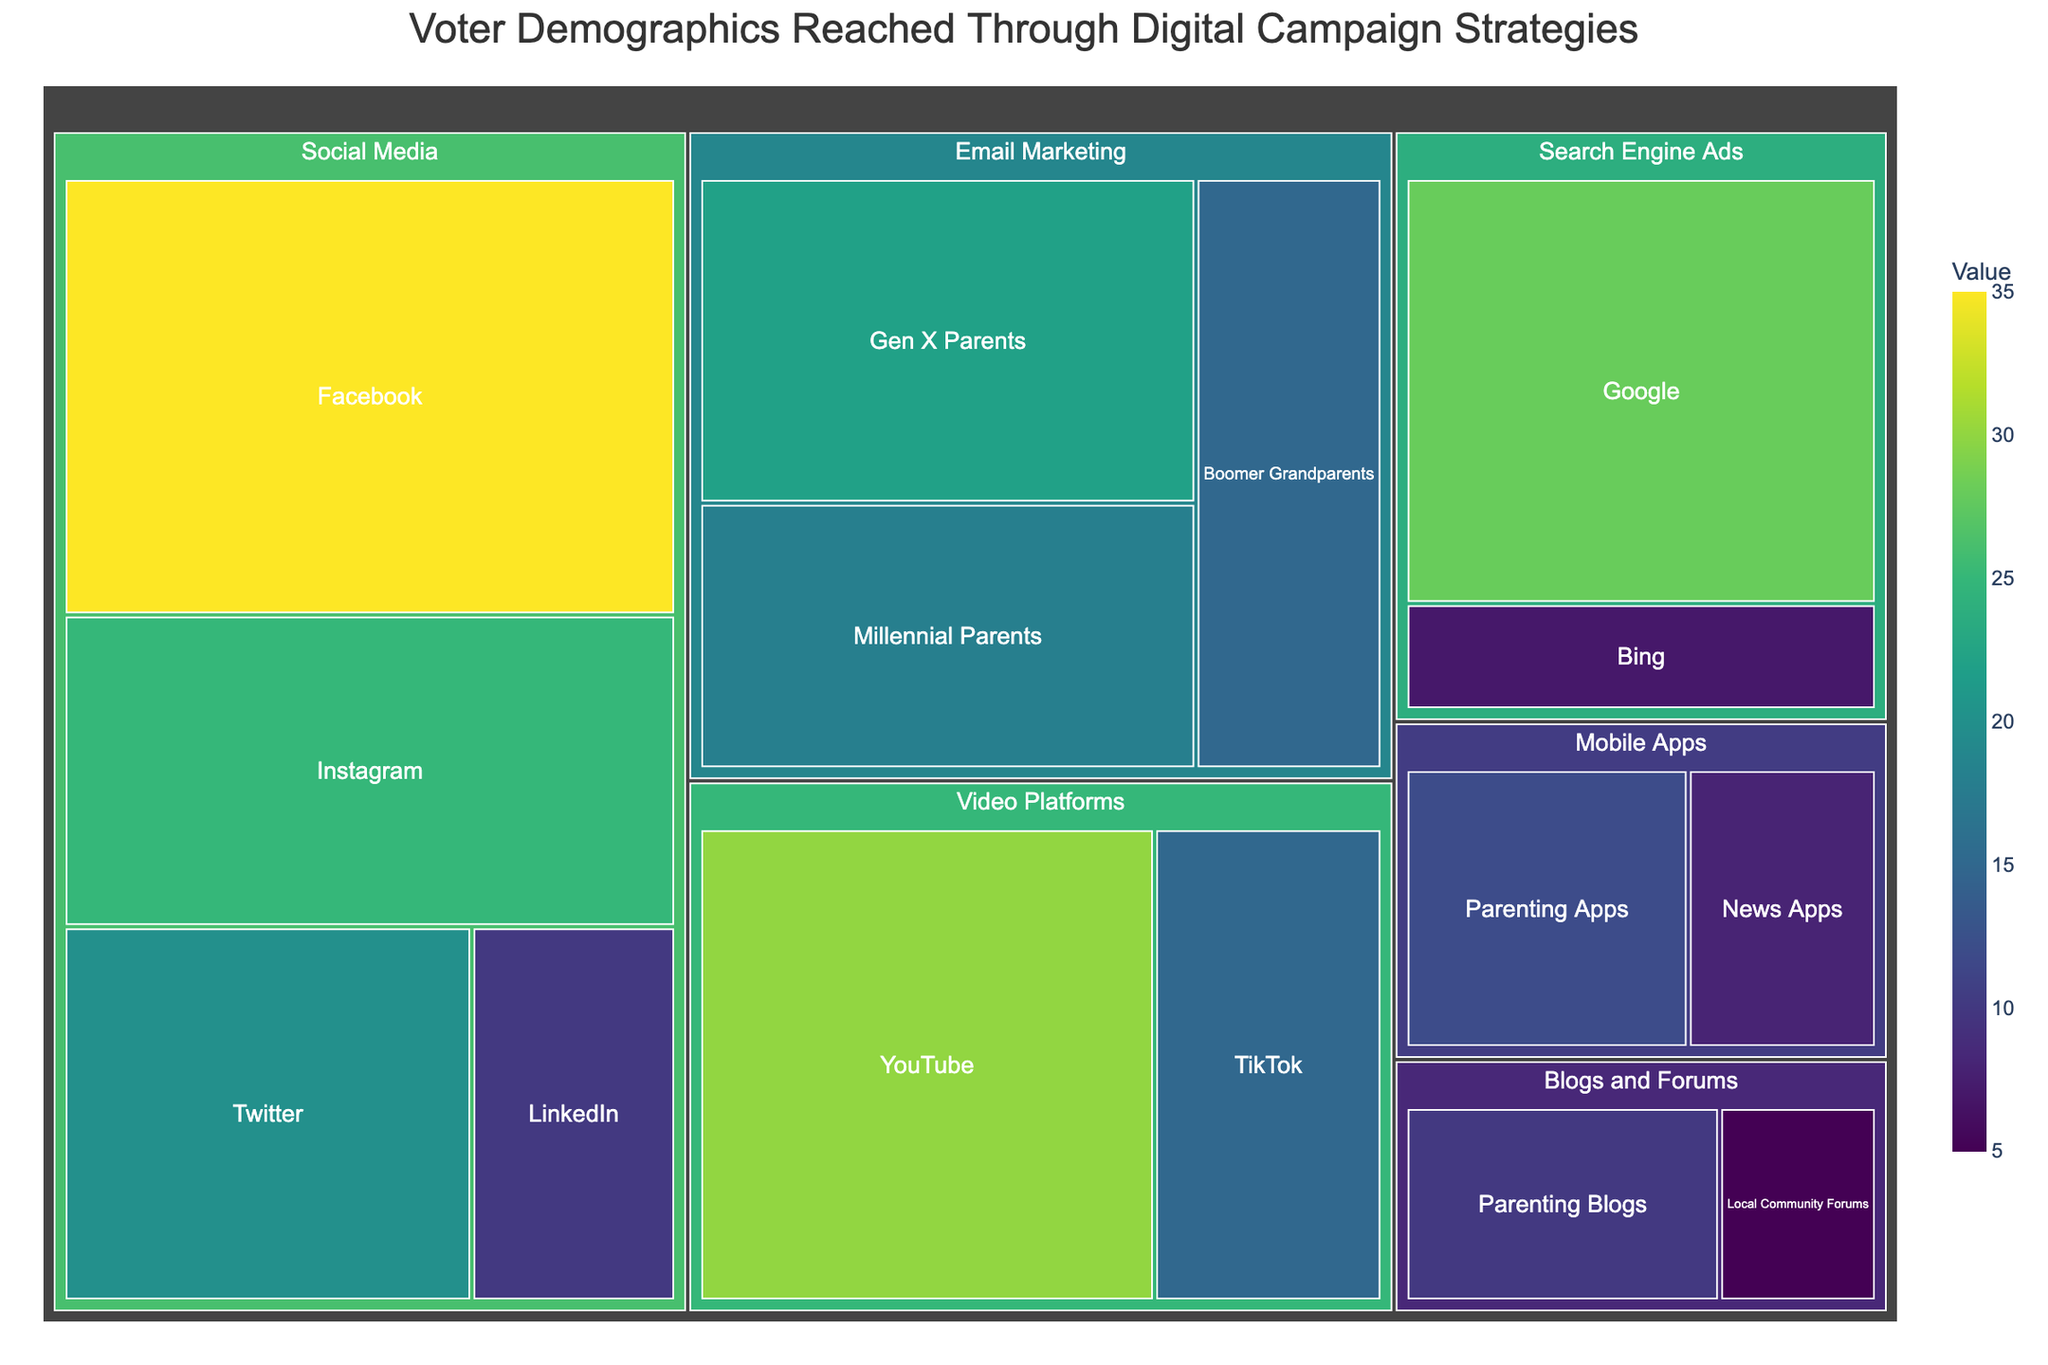what is the title of the figure? The title is often placed at the top center of the figure where it is clearly visible. Here, the treemap title is displayed at the top.
Answer: Voter Demographics Reached Through Digital Campaign Strategies which subcategory under "Social Media" has the highest value? In the "Social Media" category, the values of each subcategory are indicated. By comparing the values of Facebook, Instagram, Twitter, and LinkedIn, Facebook has the highest value of 35.
Answer: Facebook how many subcategories are there in the "Email Marketing" category? The treemap shows multiple subcategories under each category. The "Email Marketing" category has subcategories listed as Millennial Parents, Gen X Parents, and Boomer Grandparents. By counting these, we find there are three subcategories.
Answer: 3 what is the combined value of all subcategories under "Video Platforms"? Adding the values of YouTube (30) and TikTok (15) under the "Video Platforms" category, we get a combined value of 45.
Answer: 45 which category has the smallest total value? Evaluate the total value of each category by summing their subcategories' values. Categories such as Social Media, Email Marketing, etc., have summed values. The "Blogs and Forums" category has subcategories with values of Parenting Blogs (10) and Local Community Forums (5), summing to 15, which is the smallest among all categories.
Answer: Blogs and Forums what is the difference in value between YouTube and Google Ads? The value for YouTube is 30, and Google Ads is 28. Subtracting these values gives the difference, which is 2.
Answer: 2 visualize the categories to which parenting-targeted subcategories belong and their total values Within the figure, subcategories targeting parents are under categories like "Email Marketing" and "Mobile Apps." Summing the values: Millennial Parents (18) + Gen X Parents (22) + Boomer Grandparents (15) + Parenting Apps (12) = 67.
Answer: Email Marketing and Mobile Apps, total value is 67 how does the value of Parenting Apps compare to News Apps in the "Mobile Apps" category? The values under the "Mobile Apps" category show Parenting Apps as having value 12 and News Apps as having value 8. Parenting Apps has a higher value than News Apps.
Answer: Parenting Apps has a higher value than News Apps what is the color scale used in the treemap, and how does it relate to the values? The figure uses a color scale to visually represent values, varying from lighter to darker shades. Here, "Viridis" color scale is used, where different shades indicate different values, with darker colors representing higher values.
Answer: Viridis color scale, darker means higher values 